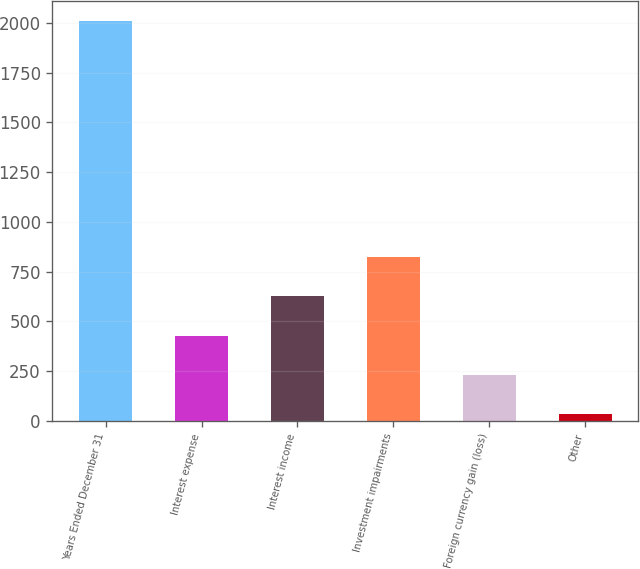Convert chart to OTSL. <chart><loc_0><loc_0><loc_500><loc_500><bar_chart><fcel>Years Ended December 31<fcel>Interest expense<fcel>Interest income<fcel>Investment impairments<fcel>Foreign currency gain (loss)<fcel>Other<nl><fcel>2008<fcel>428<fcel>625.5<fcel>823<fcel>230.5<fcel>33<nl></chart> 